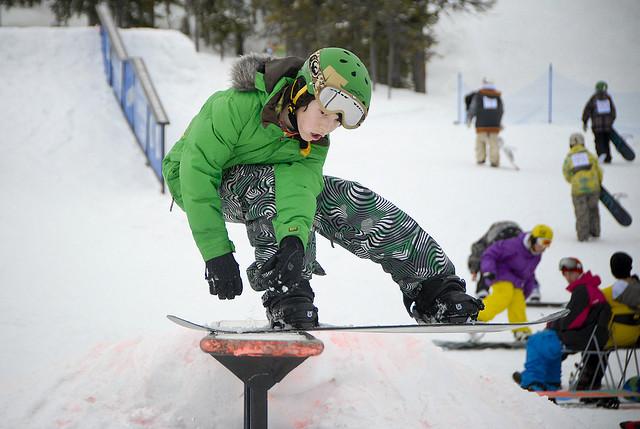Do the people know each other?
Keep it brief. Yes. What are they on?
Answer briefly. Snowboard. Are the goggles covering their eyes?
Keep it brief. No. What color is this person's helmet?
Answer briefly. Green. What season was this picture taken?
Be succinct. Winter. 